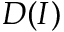<formula> <loc_0><loc_0><loc_500><loc_500>D ( I )</formula> 